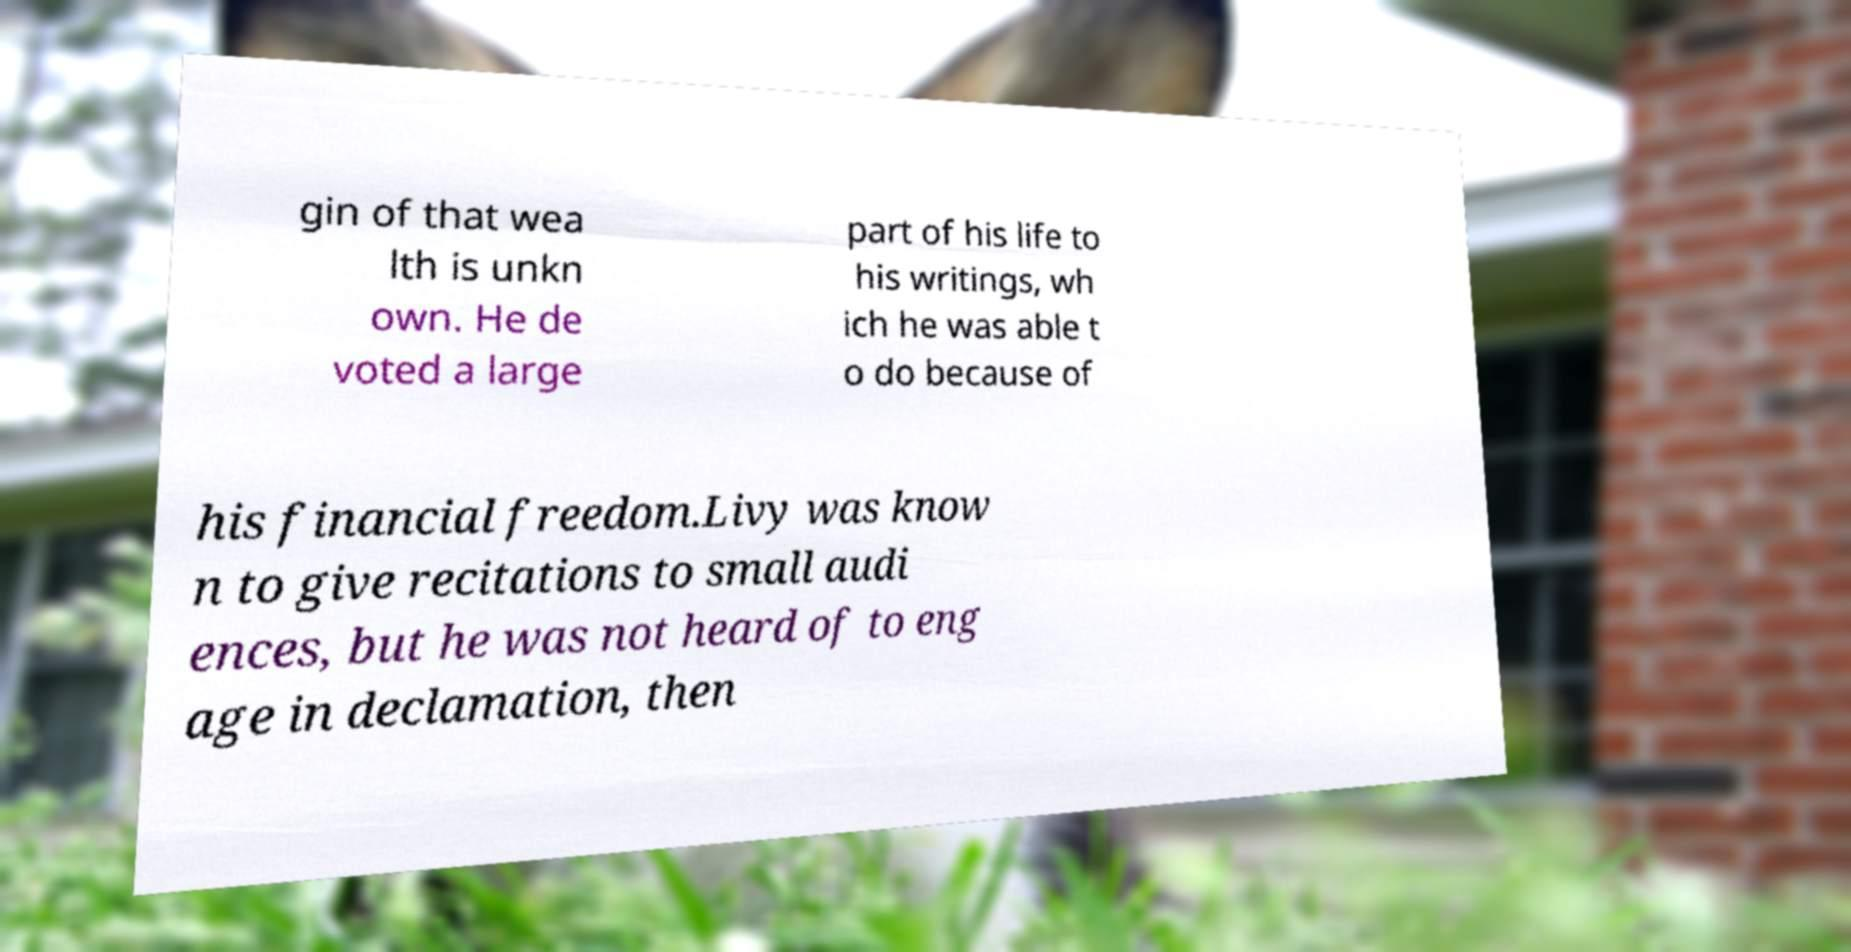What messages or text are displayed in this image? I need them in a readable, typed format. gin of that wea lth is unkn own. He de voted a large part of his life to his writings, wh ich he was able t o do because of his financial freedom.Livy was know n to give recitations to small audi ences, but he was not heard of to eng age in declamation, then 